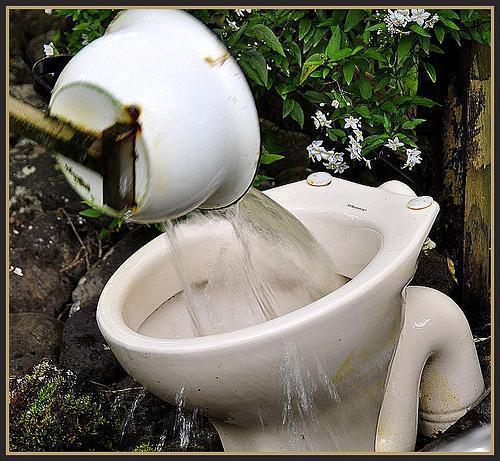How many dogs are wearing a chain collar?
Give a very brief answer. 0. 